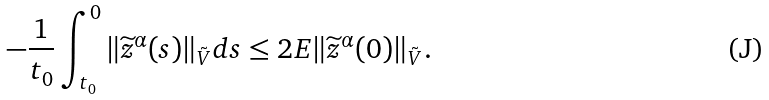<formula> <loc_0><loc_0><loc_500><loc_500>- \frac { 1 } { t _ { 0 } } \int _ { t _ { 0 } } ^ { 0 } \| \widetilde { z } ^ { \alpha } ( s ) \| _ { \tilde { V } } d s \leq 2 E \| \widetilde { z } ^ { \alpha } ( 0 ) \| _ { \tilde { V } } .</formula> 